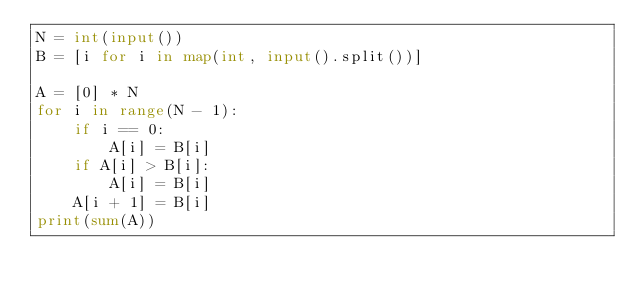<code> <loc_0><loc_0><loc_500><loc_500><_Python_>N = int(input())
B = [i for i in map(int, input().split())]

A = [0] * N
for i in range(N - 1):
    if i == 0:
        A[i] = B[i]
    if A[i] > B[i]:
        A[i] = B[i]
    A[i + 1] = B[i]
print(sum(A))
</code> 